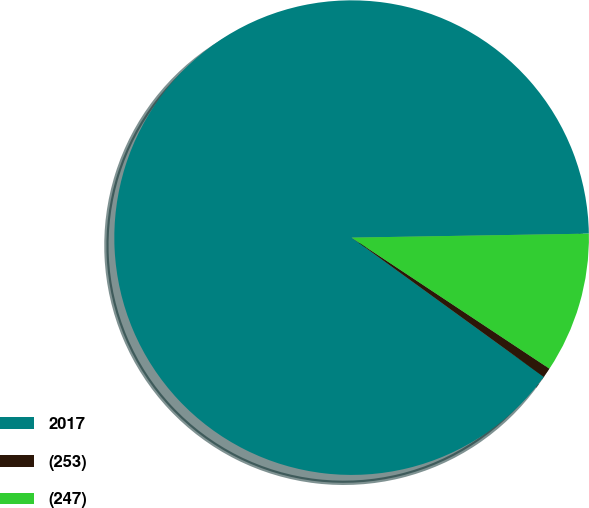Convert chart to OTSL. <chart><loc_0><loc_0><loc_500><loc_500><pie_chart><fcel>2017<fcel>(253)<fcel>(247)<nl><fcel>89.76%<fcel>0.67%<fcel>9.58%<nl></chart> 